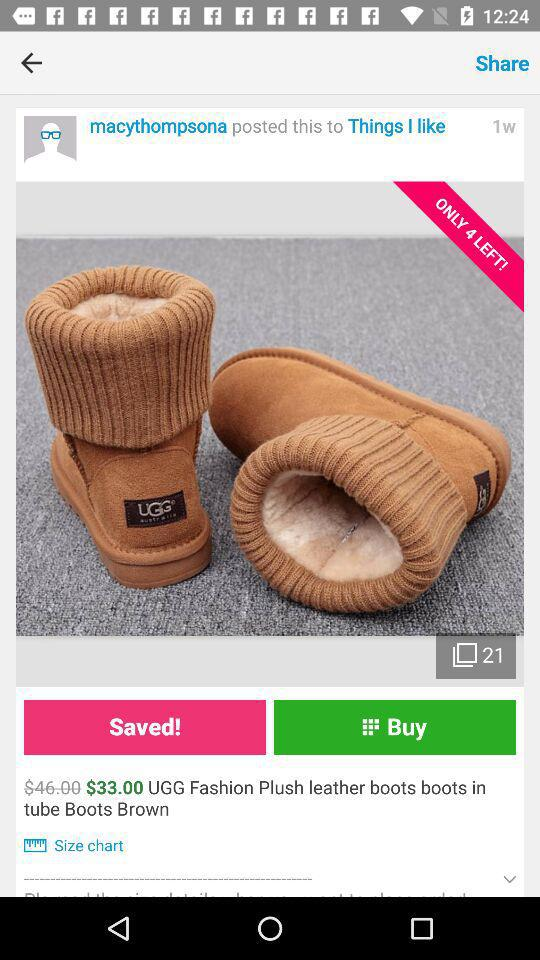How much more is the original price than the sale price?
Answer the question using a single word or phrase. $13.00 